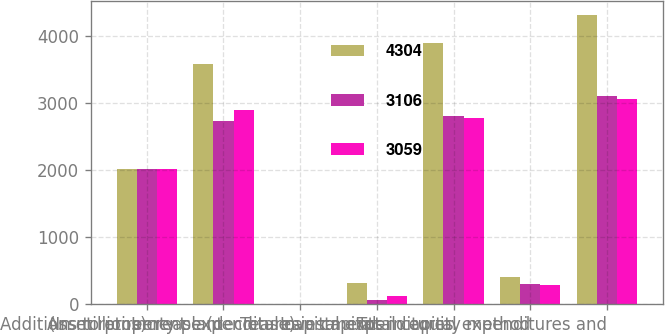<chart> <loc_0><loc_0><loc_500><loc_500><stacked_bar_chart><ecel><fcel>(In millions)<fcel>Additions to property plant<fcel>Asset retirement expenditures<fcel>Increase (decrease) in capital<fcel>Total capital expenditures<fcel>Investments in equity method<fcel>Total capital expenditures and<nl><fcel>4304<fcel>2018<fcel>3578<fcel>8<fcel>309<fcel>3895<fcel>409<fcel>4304<nl><fcel>3106<fcel>2017<fcel>2732<fcel>2<fcel>67<fcel>2801<fcel>305<fcel>3106<nl><fcel>3059<fcel>2016<fcel>2892<fcel>6<fcel>127<fcel>2771<fcel>288<fcel>3059<nl></chart> 